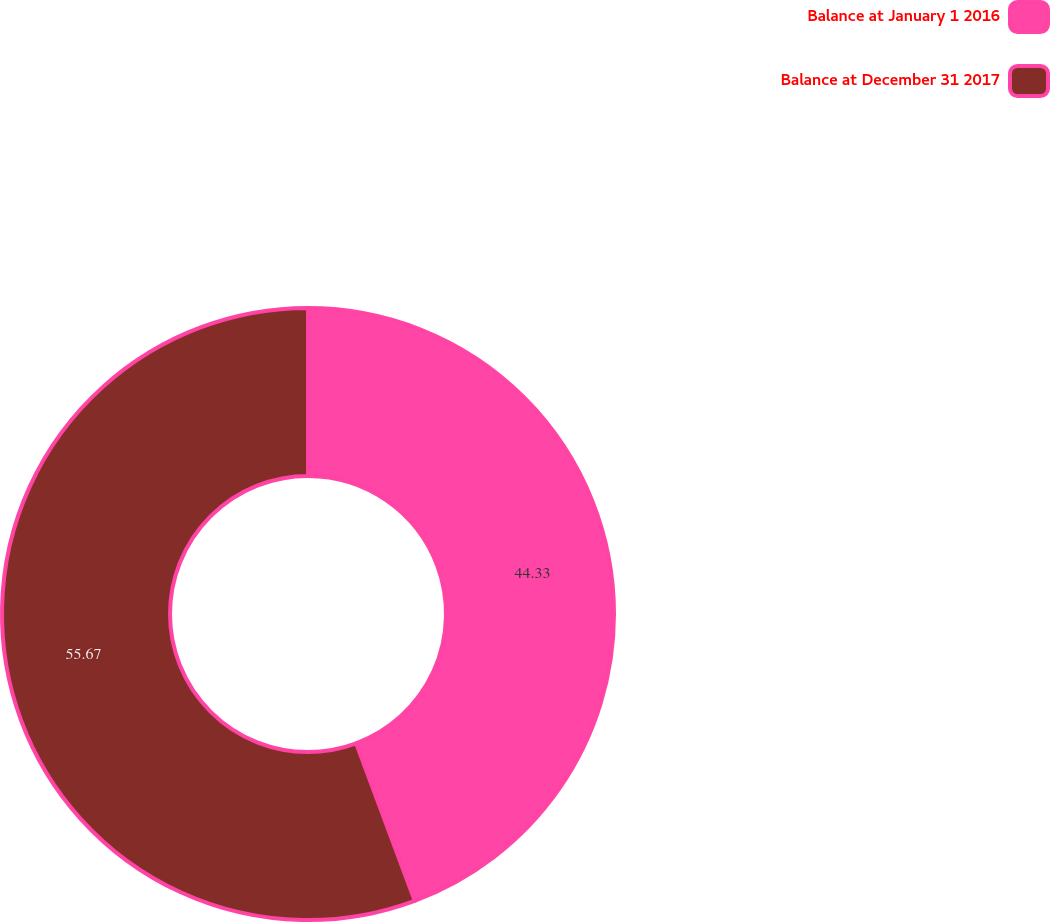Convert chart. <chart><loc_0><loc_0><loc_500><loc_500><pie_chart><fcel>Balance at January 1 2016<fcel>Balance at December 31 2017<nl><fcel>44.33%<fcel>55.67%<nl></chart> 